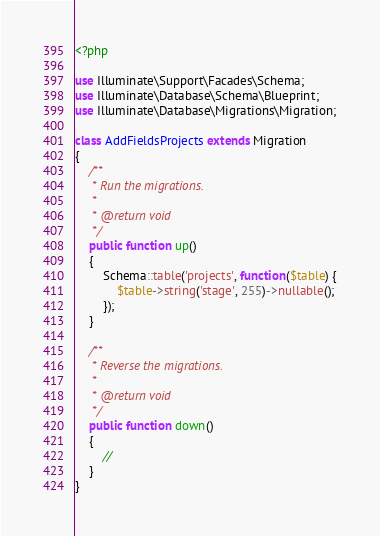Convert code to text. <code><loc_0><loc_0><loc_500><loc_500><_PHP_><?php

use Illuminate\Support\Facades\Schema;
use Illuminate\Database\Schema\Blueprint;
use Illuminate\Database\Migrations\Migration;

class AddFieldsProjects extends Migration
{
    /**
     * Run the migrations.
     *
     * @return void
     */
    public function up()
    {
        Schema::table('projects', function($table) {
            $table->string('stage', 255)->nullable();
        });
    }

    /**
     * Reverse the migrations.
     *
     * @return void
     */
    public function down()
    {
        //
    }
}
</code> 